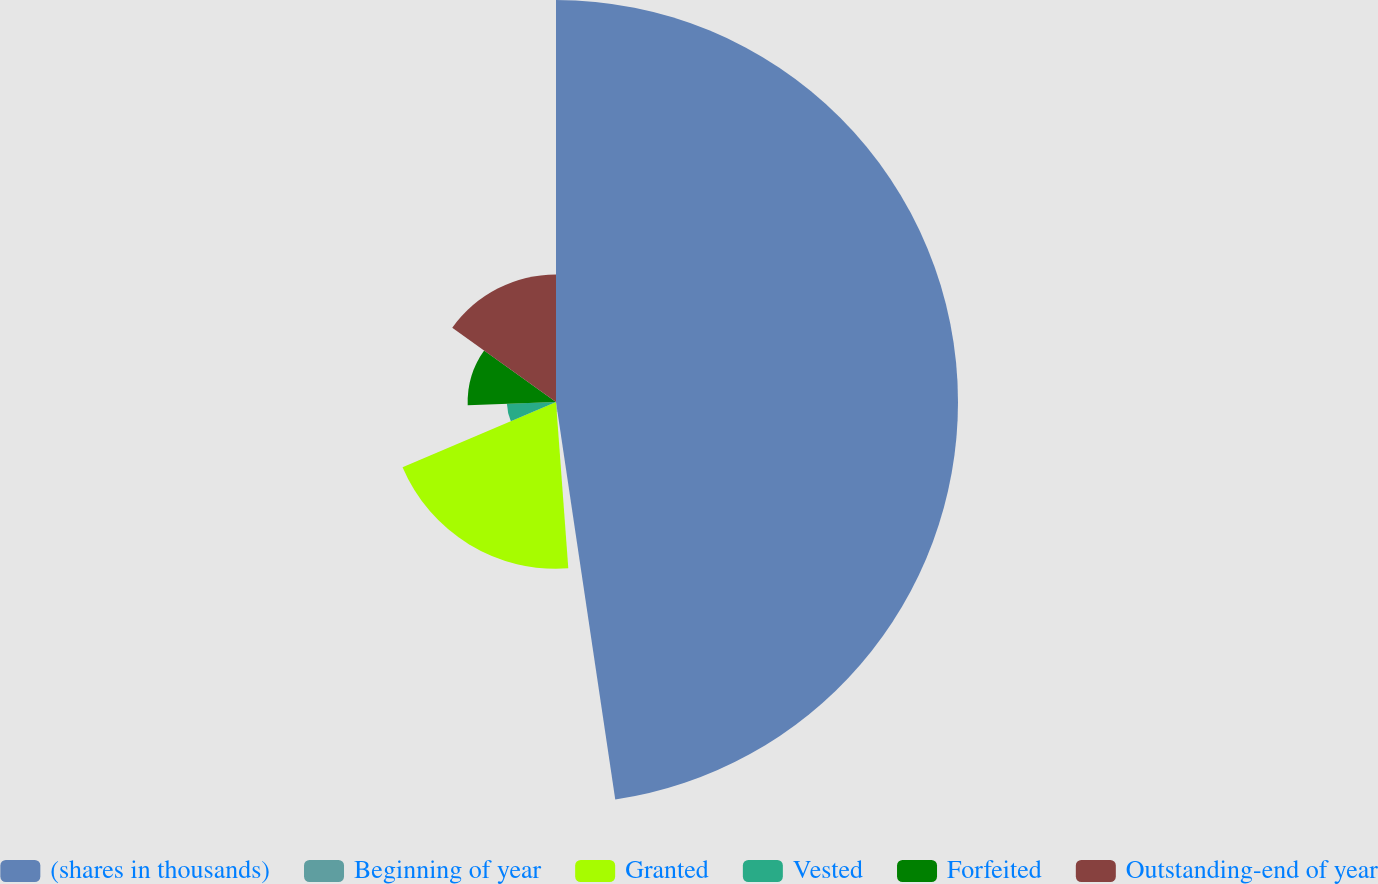Convert chart to OTSL. <chart><loc_0><loc_0><loc_500><loc_500><pie_chart><fcel>(shares in thousands)<fcel>Beginning of year<fcel>Granted<fcel>Vested<fcel>Forfeited<fcel>Outstanding-end of year<nl><fcel>47.65%<fcel>1.18%<fcel>19.77%<fcel>5.82%<fcel>10.47%<fcel>15.12%<nl></chart> 